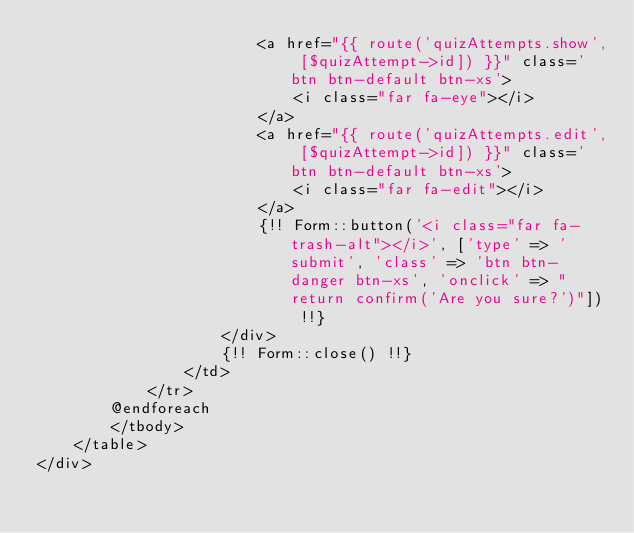Convert code to text. <code><loc_0><loc_0><loc_500><loc_500><_PHP_>                        <a href="{{ route('quizAttempts.show', [$quizAttempt->id]) }}" class='btn btn-default btn-xs'>
                            <i class="far fa-eye"></i>
                        </a>
                        <a href="{{ route('quizAttempts.edit', [$quizAttempt->id]) }}" class='btn btn-default btn-xs'>
                            <i class="far fa-edit"></i>
                        </a>
                        {!! Form::button('<i class="far fa-trash-alt"></i>', ['type' => 'submit', 'class' => 'btn btn-danger btn-xs', 'onclick' => "return confirm('Are you sure?')"]) !!}
                    </div>
                    {!! Form::close() !!}
                </td>
            </tr>
        @endforeach
        </tbody>
    </table>
</div>
</code> 